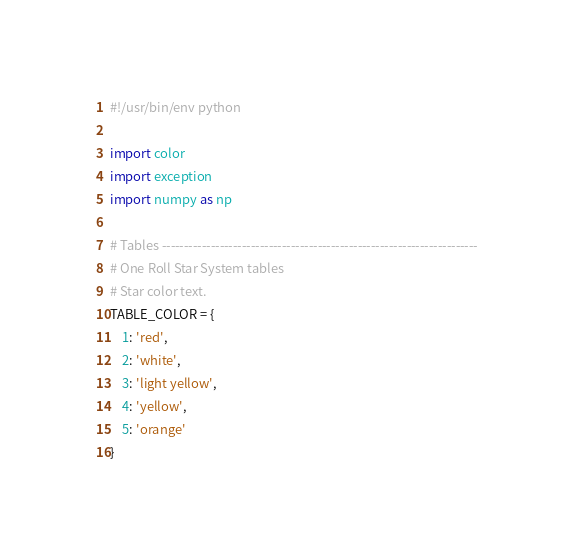Convert code to text. <code><loc_0><loc_0><loc_500><loc_500><_Python_>#!/usr/bin/env python

import color
import exception
import numpy as np

# Tables -----------------------------------------------------------------------
# One Roll Star System tables
# Star color text.
TABLE_COLOR = {
    1: 'red',
    2: 'white',
    3: 'light yellow',
    4: 'yellow',
    5: 'orange'
}
</code> 